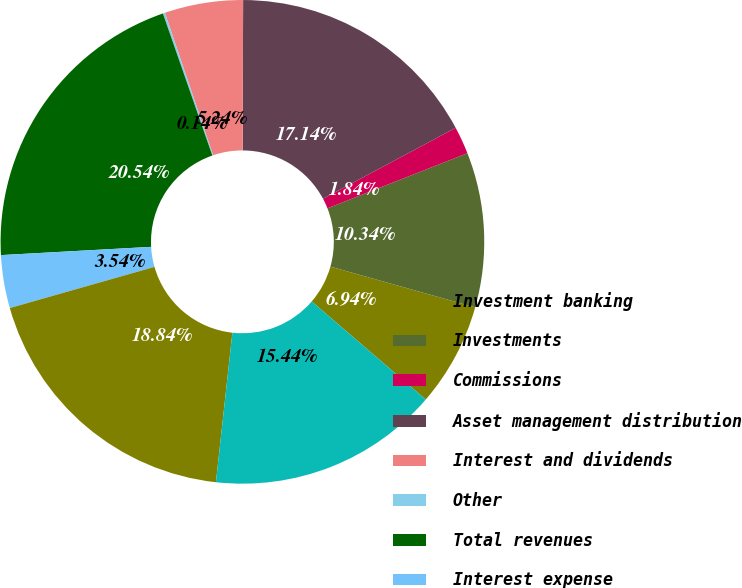Convert chart. <chart><loc_0><loc_0><loc_500><loc_500><pie_chart><fcel>Investment banking<fcel>Investments<fcel>Commissions<fcel>Asset management distribution<fcel>Interest and dividends<fcel>Other<fcel>Total revenues<fcel>Interest expense<fcel>Net revenues<fcel>Total non-interest expenses<nl><fcel>6.94%<fcel>10.34%<fcel>1.84%<fcel>17.14%<fcel>5.24%<fcel>0.14%<fcel>20.54%<fcel>3.54%<fcel>18.84%<fcel>15.44%<nl></chart> 